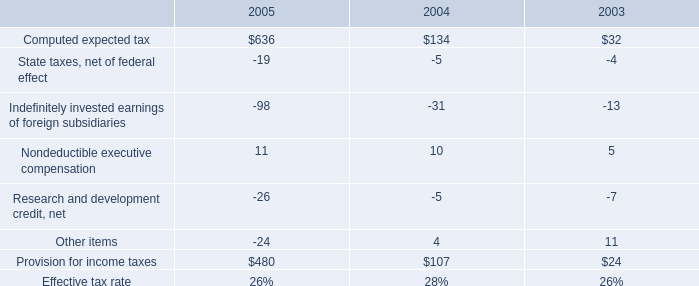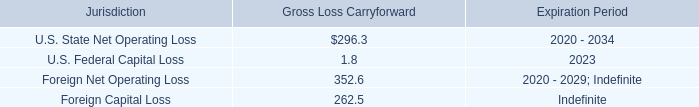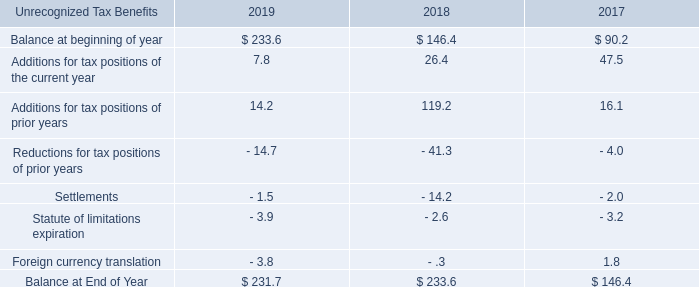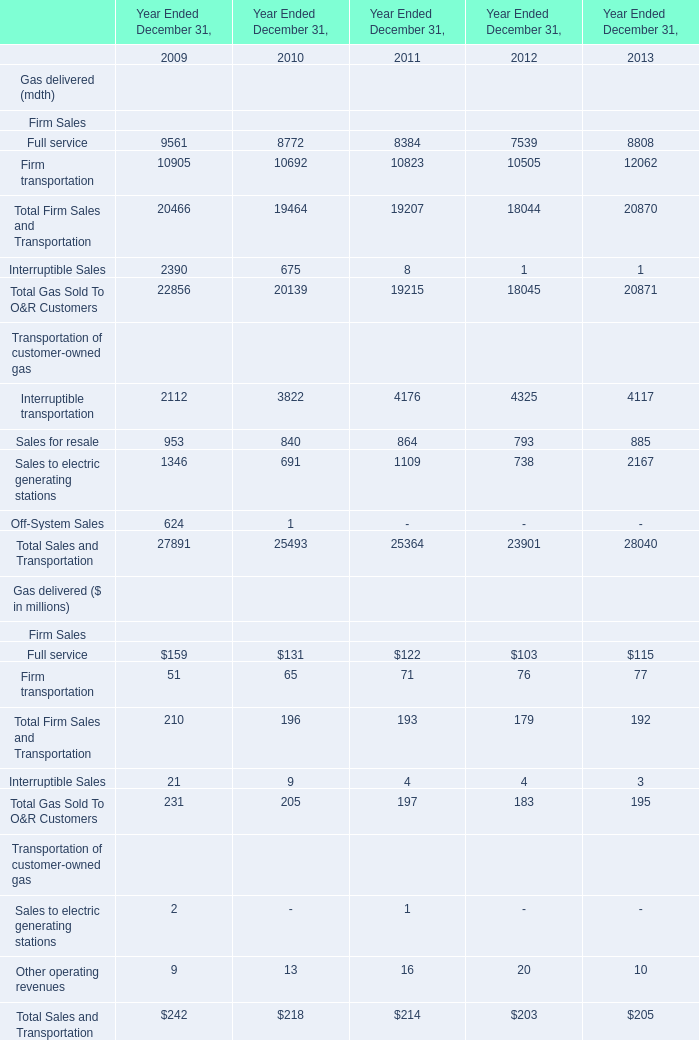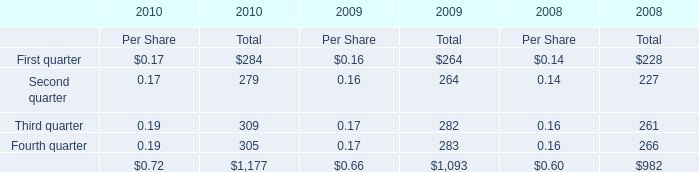When is Total Gas Sold To O&R Customers the largest in terms of Gas delivered (mdth)? 
Answer: 2009. 